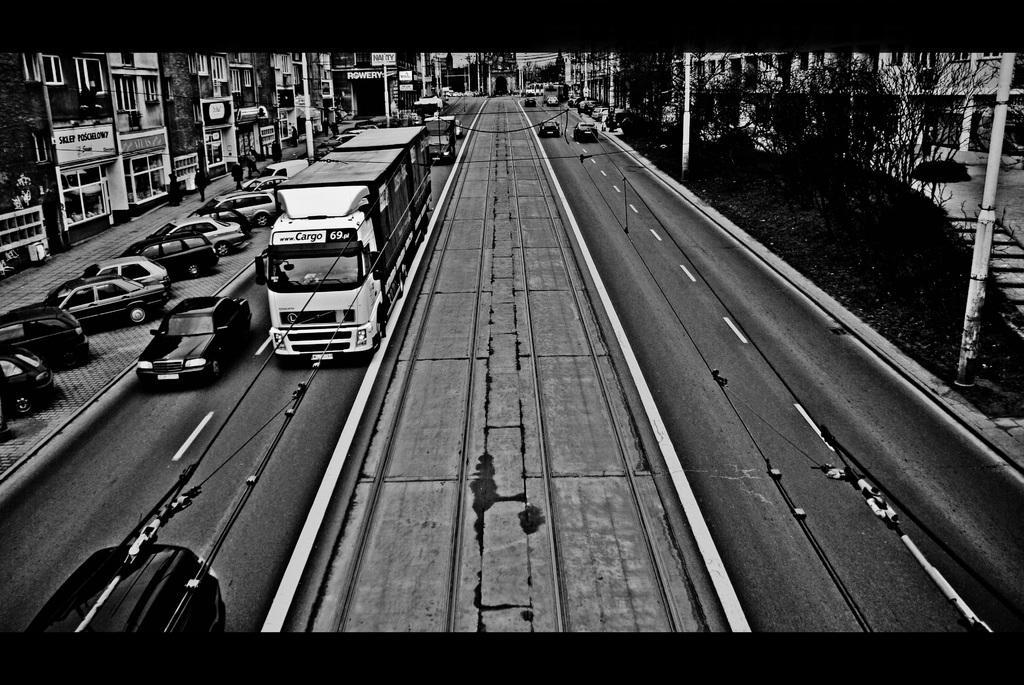Describe this image in one or two sentences. In this image I see lot of buildings, trees and a lot of vehicles on the path. 